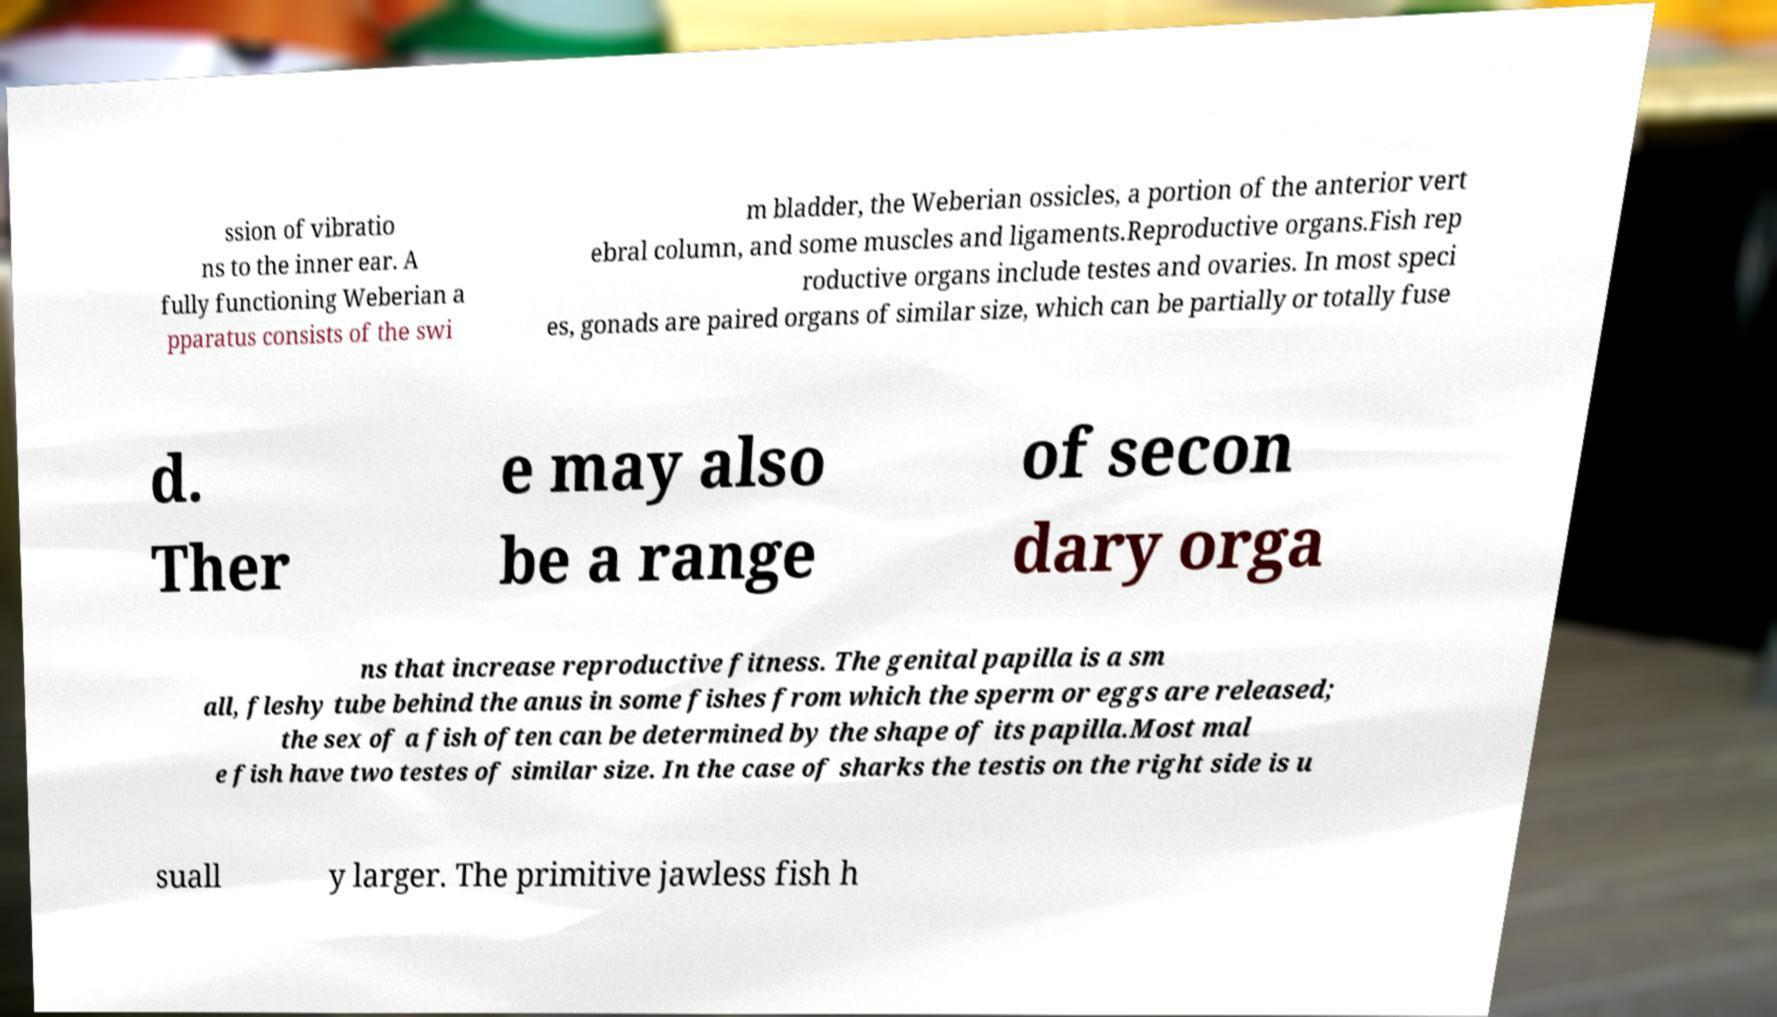I need the written content from this picture converted into text. Can you do that? ssion of vibratio ns to the inner ear. A fully functioning Weberian a pparatus consists of the swi m bladder, the Weberian ossicles, a portion of the anterior vert ebral column, and some muscles and ligaments.Reproductive organs.Fish rep roductive organs include testes and ovaries. In most speci es, gonads are paired organs of similar size, which can be partially or totally fuse d. Ther e may also be a range of secon dary orga ns that increase reproductive fitness. The genital papilla is a sm all, fleshy tube behind the anus in some fishes from which the sperm or eggs are released; the sex of a fish often can be determined by the shape of its papilla.Most mal e fish have two testes of similar size. In the case of sharks the testis on the right side is u suall y larger. The primitive jawless fish h 